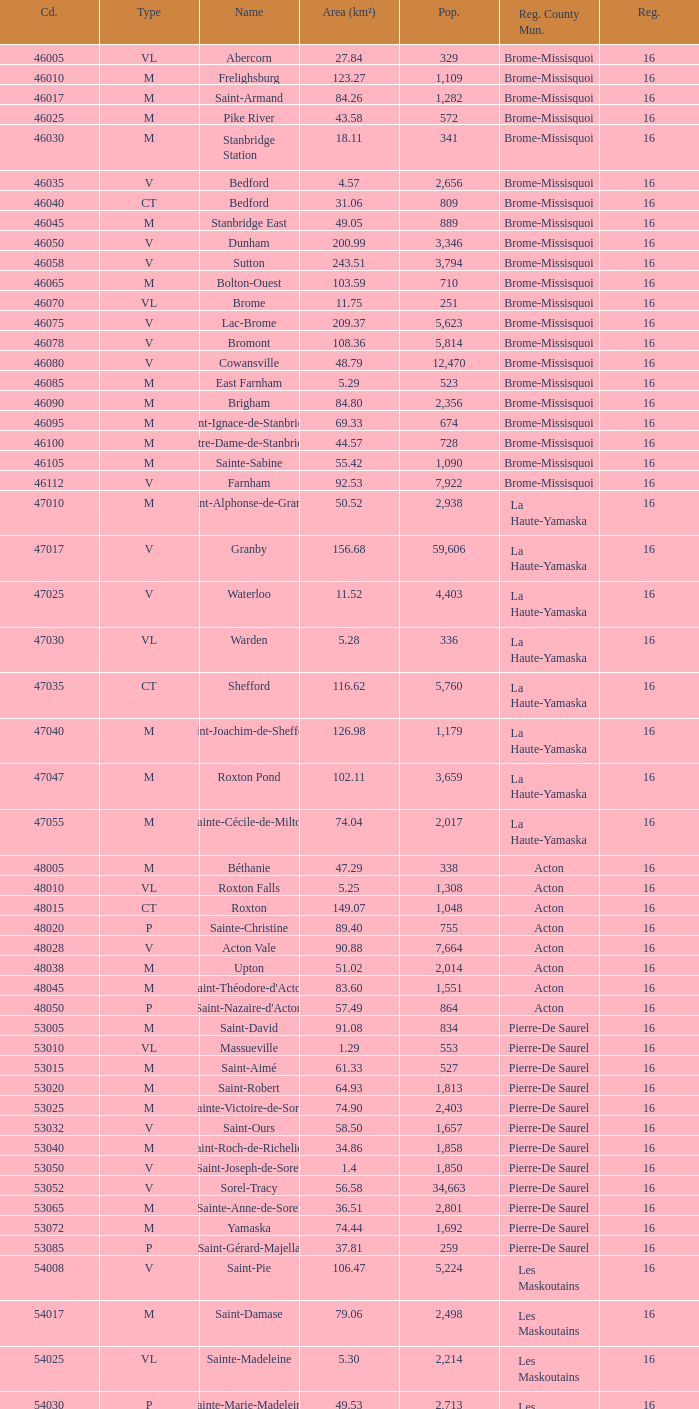What is the code for a Le Haut-Saint-Laurent municipality that has 16 or more regions? None. 